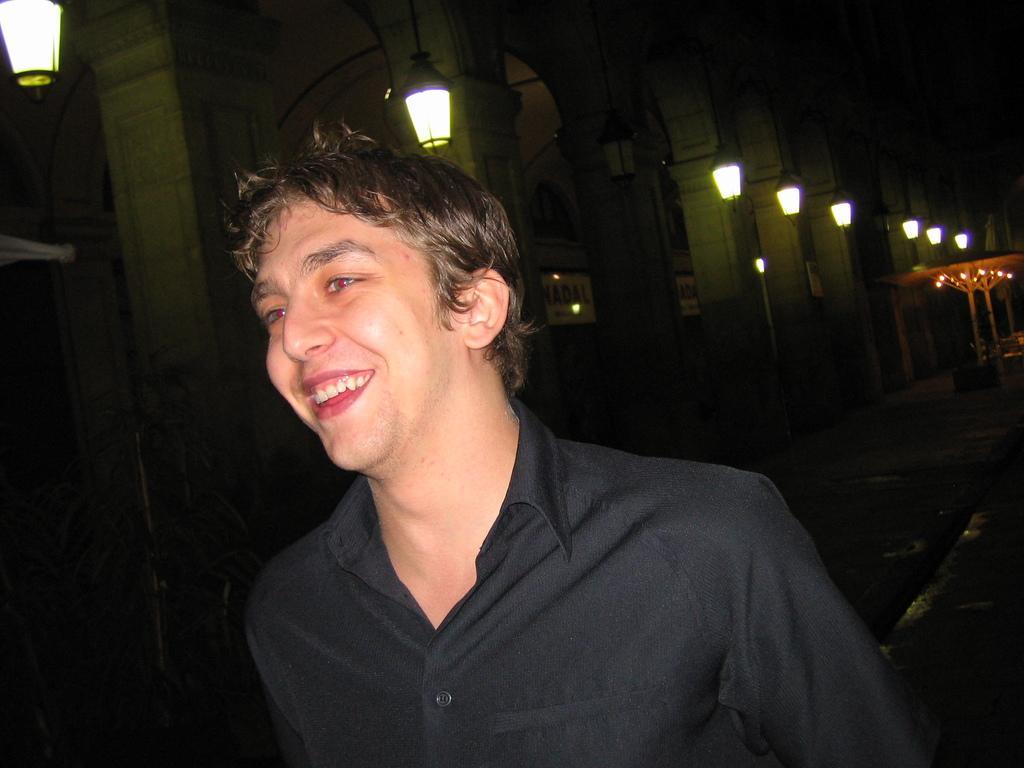What is the main subject of the image? The main subject of the subject of the image is a man. What is the man wearing in the image? The man is wearing a black shirt in the image. What is the man's facial expression in the image? The man is smiling in the image. What can be seen on the left side of the image? There is a building on the left side of the image. What is visible on the right side of the image? There are lights visible on the right side of the image. What type of honey is the man using to sweeten his coffee in the image? There is no coffee or honey present in the image; the man is simply smiling and wearing a black shirt. 